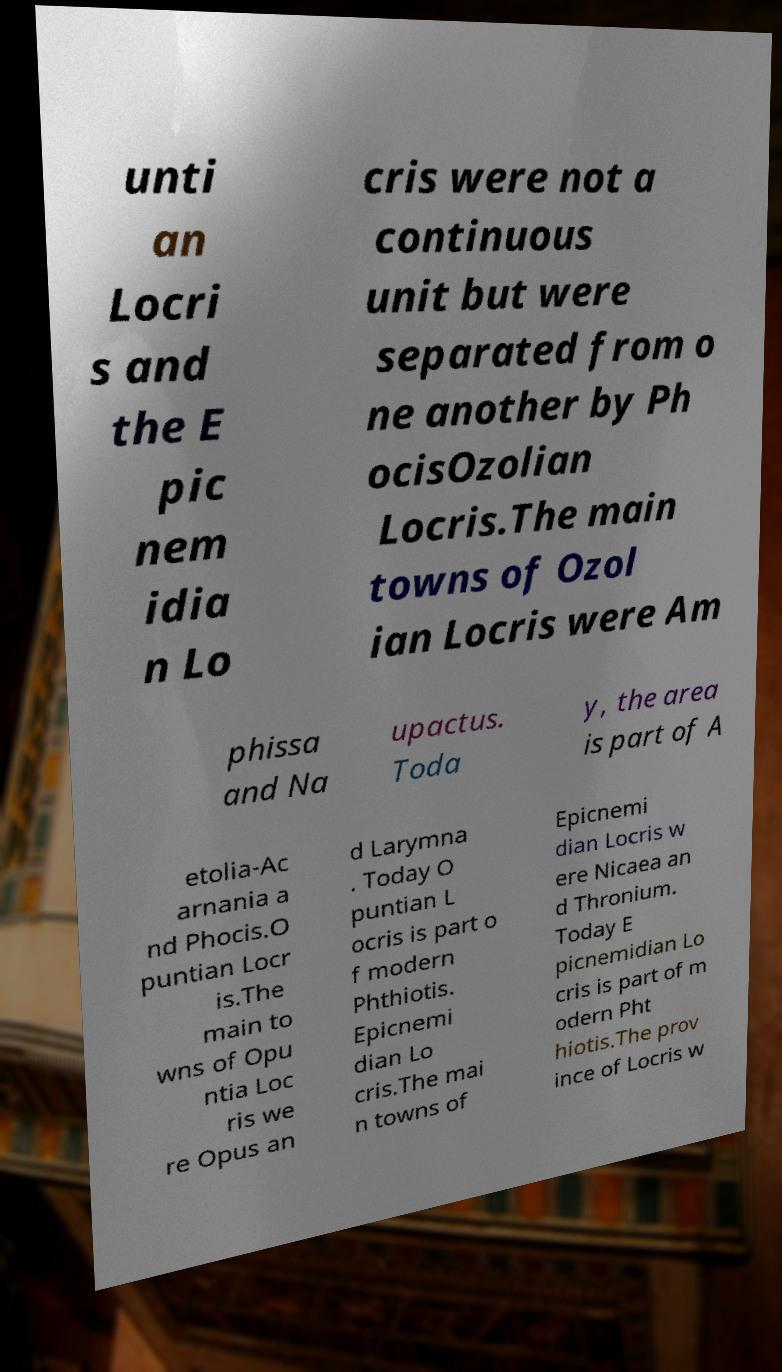There's text embedded in this image that I need extracted. Can you transcribe it verbatim? unti an Locri s and the E pic nem idia n Lo cris were not a continuous unit but were separated from o ne another by Ph ocisOzolian Locris.The main towns of Ozol ian Locris were Am phissa and Na upactus. Toda y, the area is part of A etolia-Ac arnania a nd Phocis.O puntian Locr is.The main to wns of Opu ntia Loc ris we re Opus an d Larymna . Today O puntian L ocris is part o f modern Phthiotis. Epicnemi dian Lo cris.The mai n towns of Epicnemi dian Locris w ere Nicaea an d Thronium. Today E picnemidian Lo cris is part of m odern Pht hiotis.The prov ince of Locris w 